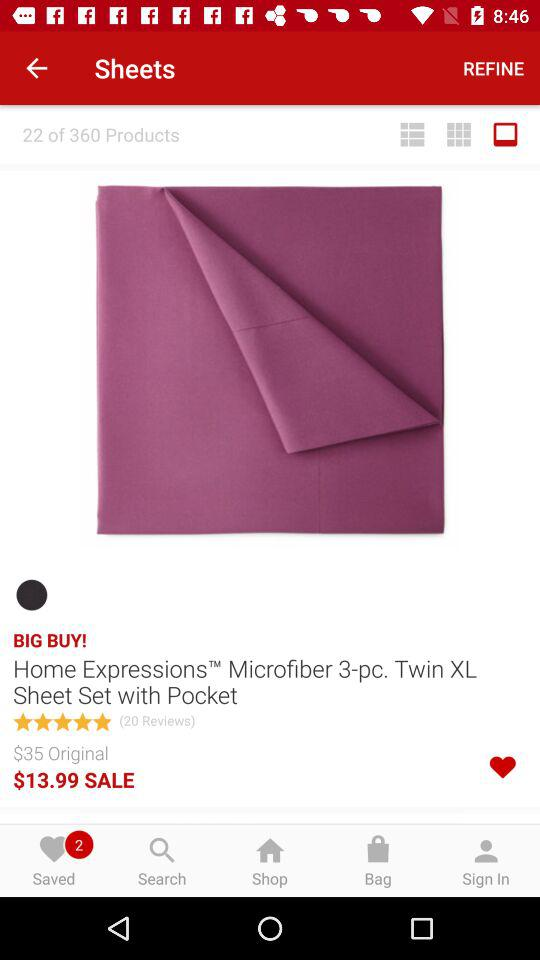What is the total number of reviews? The total number of reviews is 20. 